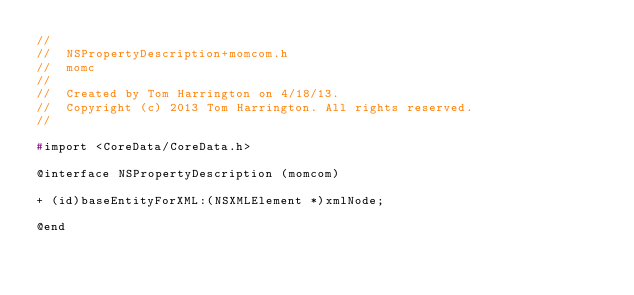<code> <loc_0><loc_0><loc_500><loc_500><_C_>//
//  NSPropertyDescription+momcom.h
//  momc
//
//  Created by Tom Harrington on 4/18/13.
//  Copyright (c) 2013 Tom Harrington. All rights reserved.
//

#import <CoreData/CoreData.h>

@interface NSPropertyDescription (momcom)

+ (id)baseEntityForXML:(NSXMLElement *)xmlNode;

@end
</code> 